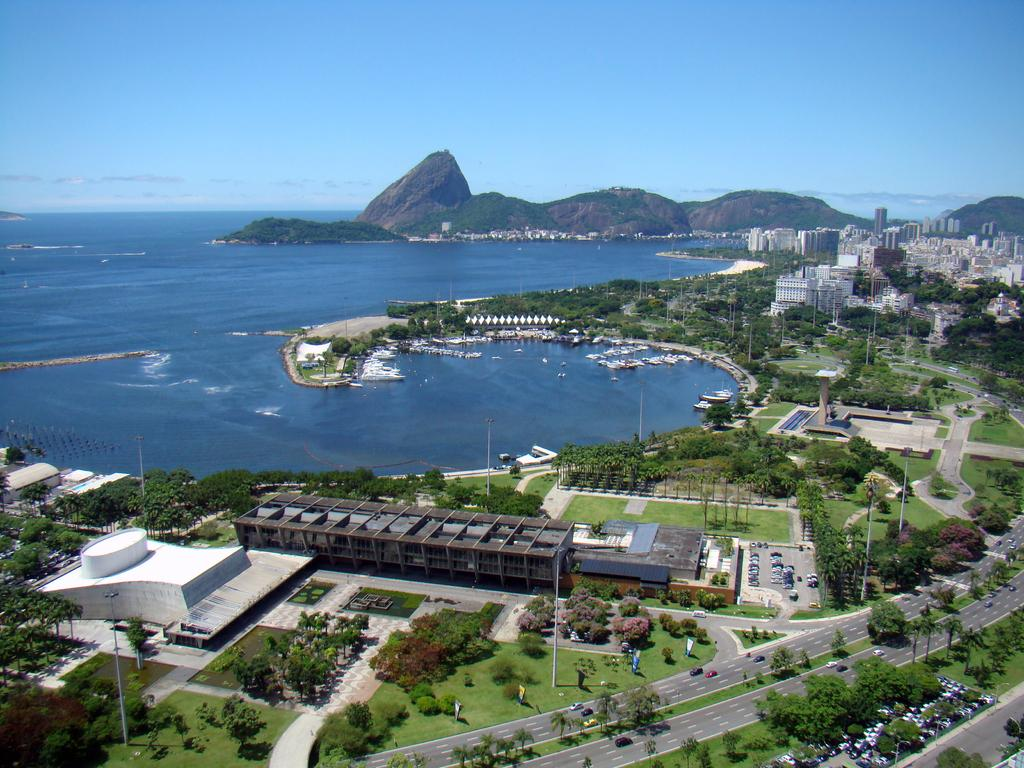What type of view is depicted in the image? The image is an aerial view. What structures can be seen in the image? There are many buildings in the image. What type of transportation infrastructure is visible? There are roads in the image. What type of natural elements can be seen in the image? There are trees and hills in the image. What type of vehicles can be seen in the image? There are vehicles in the image. What body of water is visible in the image? There is a sea visible in the image. What part of the natural environment is visible in the image? The sky is visible in the image. What type of juice is being served at the basketball game in the image? There is no juice or basketball game present in the image. 